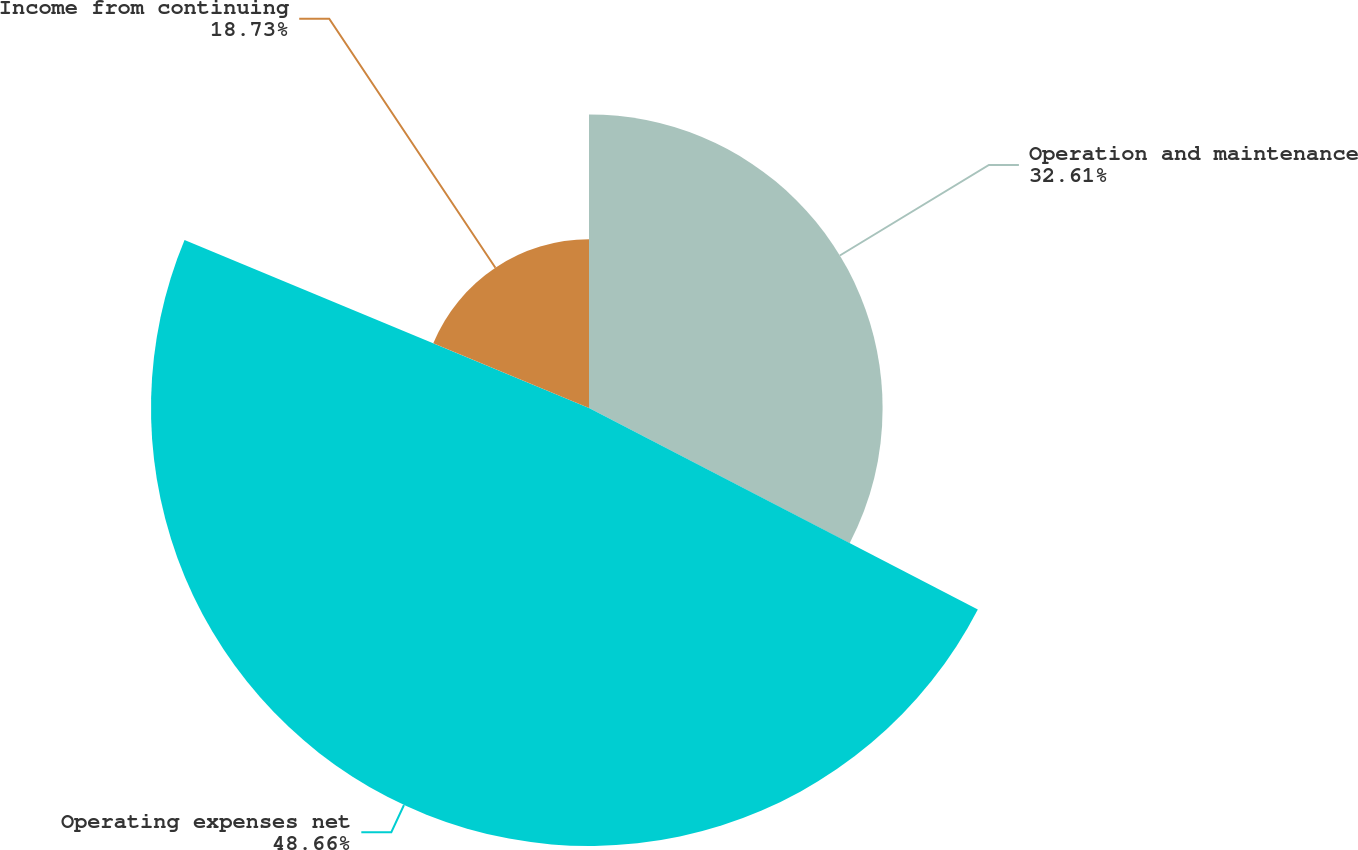<chart> <loc_0><loc_0><loc_500><loc_500><pie_chart><fcel>Operation and maintenance<fcel>Operating expenses net<fcel>Income from continuing<nl><fcel>32.61%<fcel>48.65%<fcel>18.73%<nl></chart> 